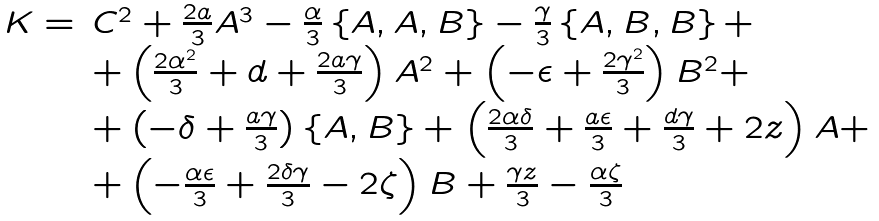<formula> <loc_0><loc_0><loc_500><loc_500>\begin{array} { r l } K = & C ^ { 2 } + \frac { 2 a } { 3 } A ^ { 3 } - \frac { \alpha } { 3 } \left \{ A , A , B \right \} - \frac { \gamma } { 3 } \left \{ A , B , B \right \} + \\ & + \left ( { \frac { 2 { \alpha ^ { 2 } } } { 3 } } + d + { \frac { 2 a \gamma } { 3 } } \right ) A ^ { 2 } + \left ( - \epsilon + \frac { 2 \gamma ^ { 2 } } { 3 } \right ) B ^ { 2 } + \\ & + \left ( - \delta + \frac { a \gamma } { 3 } \right ) \{ A , B \} + \left ( \frac { 2 \alpha \delta } { 3 } + \frac { a \epsilon } { 3 } + \frac { d \gamma } { 3 } + 2 z \right ) A + \\ & + \left ( - \frac { \alpha \epsilon } { 3 } + \frac { 2 \delta \gamma } { 3 } - 2 \zeta \right ) B + \frac { \gamma z } { 3 } - \frac { \alpha \zeta } { 3 } \end{array}</formula> 